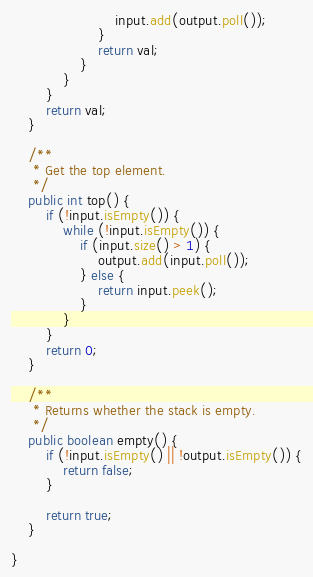Convert code to text. <code><loc_0><loc_0><loc_500><loc_500><_Java_>                        input.add(output.poll());
                    }
                    return val;
                }
            }
        }
        return val;
    }

    /**
     * Get the top element.
     */
    public int top() {
        if (!input.isEmpty()) {
            while (!input.isEmpty()) {
                if (input.size() > 1) {
                    output.add(input.poll());
                } else {
                    return input.peek();
                }
            }
        }
        return 0;
    }

    /**
     * Returns whether the stack is empty.
     */
    public boolean empty() {
        if (!input.isEmpty() || !output.isEmpty()) {
            return false;
        }

        return true;
    }

}
</code> 